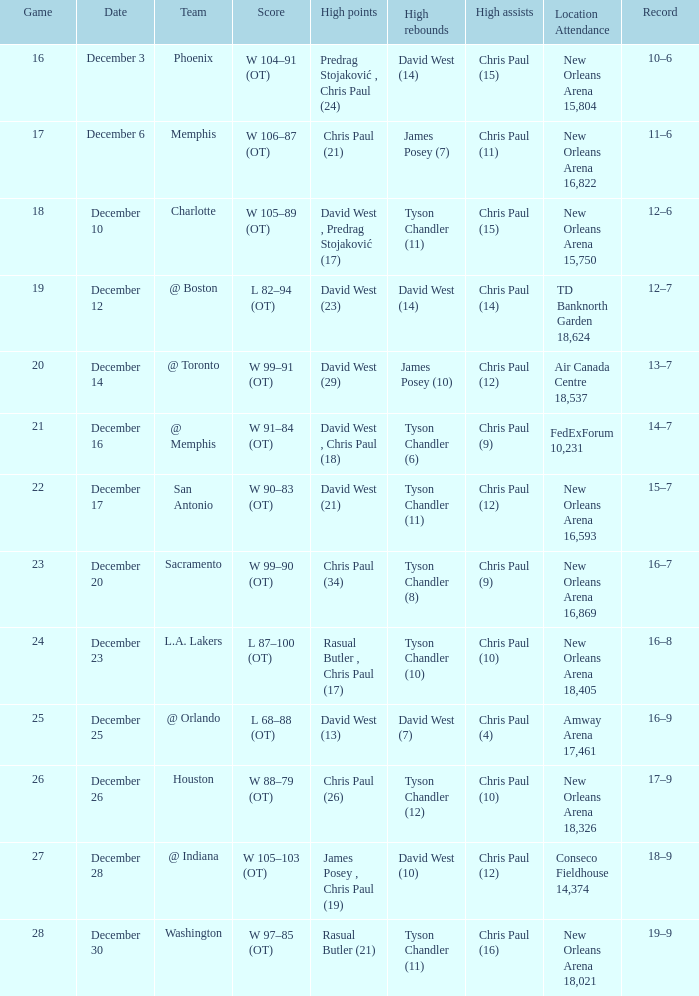What is the result, when team is "@ memphis"? W 91–84 (OT). 